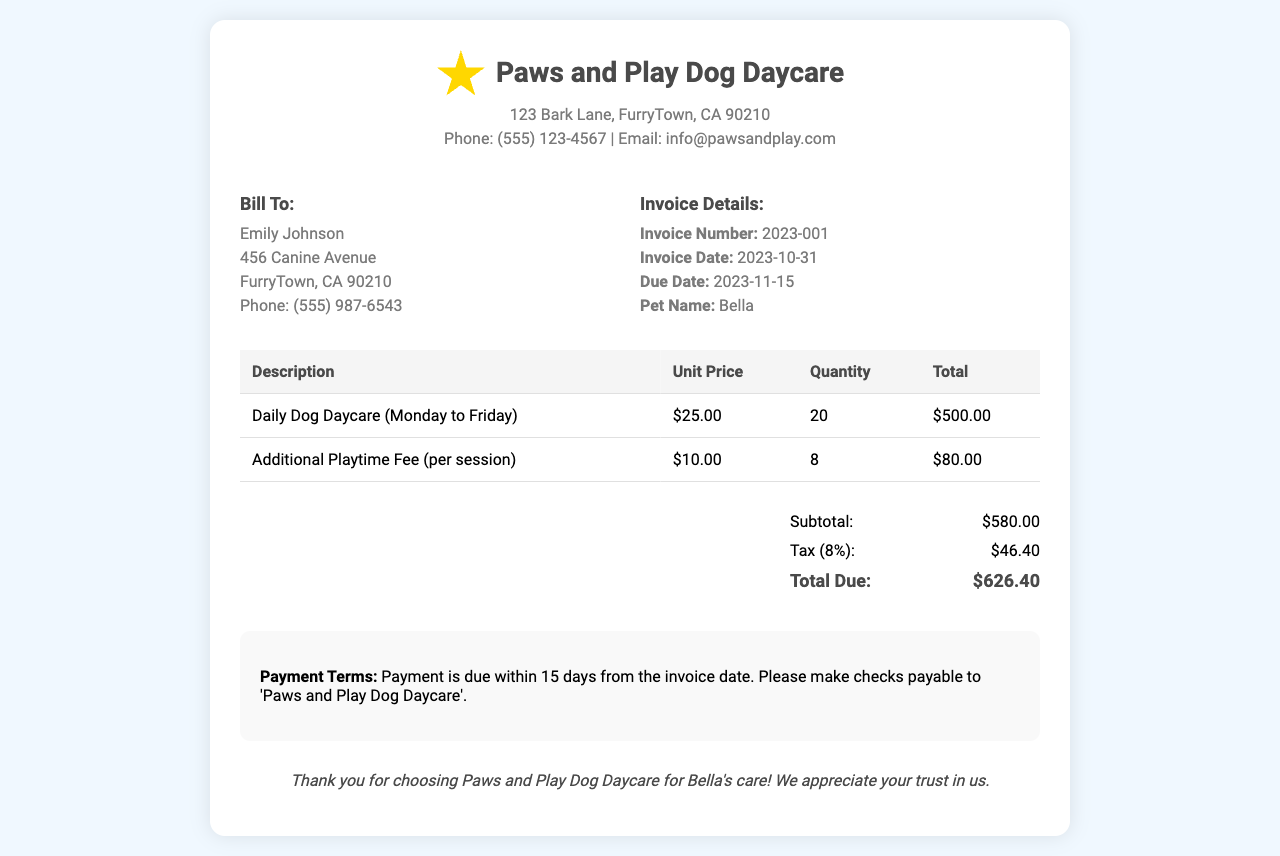what is the invoice number? The invoice number is stated under the invoice details section, which is 2023-001.
Answer: 2023-001 what is the subtotal amount? The subtotal amount is indicated in the summary section, which is $580.00.
Answer: $580.00 who is the pet's owner? The pet's owner is mentioned in the billing section as Emily Johnson.
Answer: Emily Johnson how many additional playtime sessions were charged? The number of additional playtime sessions is shown in the table, which is 8 sessions.
Answer: 8 what is the total due amount? The total due amount is located in the summary section and is $626.40.
Answer: $626.40 what is the due date for the payment? The due date is provided in the invoice details section, which is 2023-11-15.
Answer: 2023-11-15 what is the tax percentage on the invoice? The tax percentage is mentioned in the summary section, which is 8%.
Answer: 8% how many days do I have to make the payment? The payment terms specify that payment is due within 15 days from the invoice date.
Answer: 15 days 